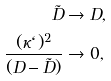Convert formula to latex. <formula><loc_0><loc_0><loc_500><loc_500>\tilde { D } & \rightarrow D , \\ \frac { ( \kappa \ell ) ^ { 2 } } { ( D - \tilde { D } ) } & \rightarrow 0 ,</formula> 